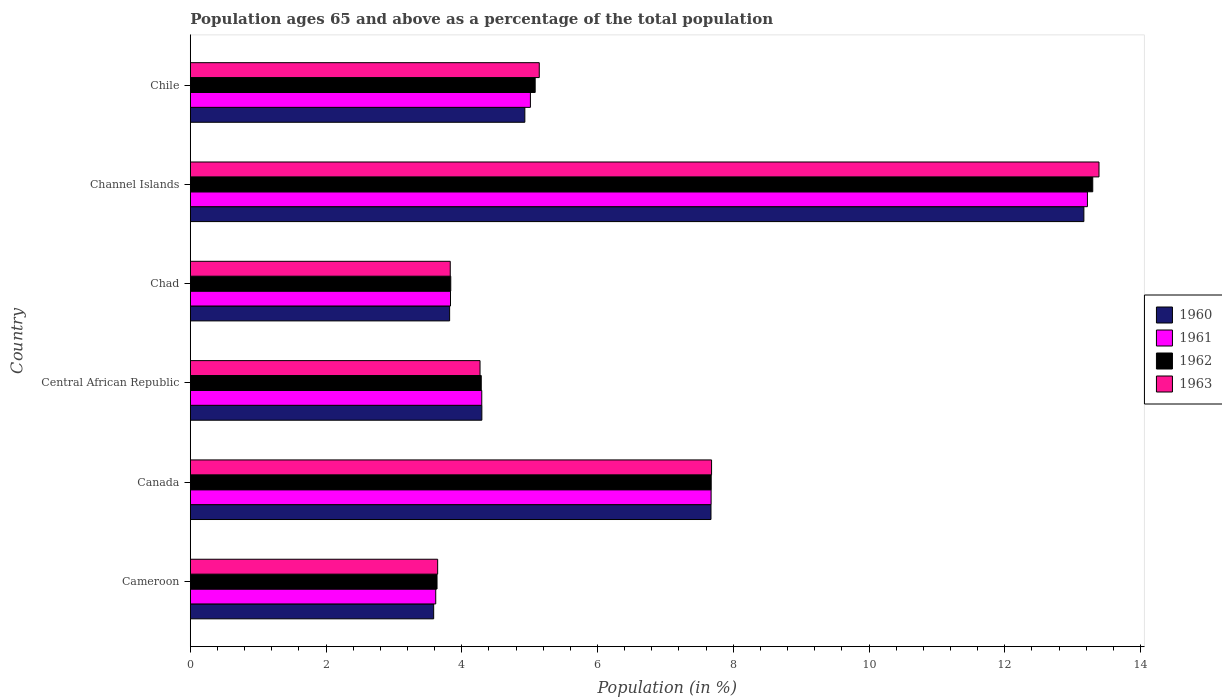How many groups of bars are there?
Offer a terse response. 6. Are the number of bars per tick equal to the number of legend labels?
Make the answer very short. Yes. Are the number of bars on each tick of the Y-axis equal?
Your answer should be very brief. Yes. How many bars are there on the 6th tick from the bottom?
Your answer should be compact. 4. What is the label of the 2nd group of bars from the top?
Offer a very short reply. Channel Islands. In how many cases, is the number of bars for a given country not equal to the number of legend labels?
Ensure brevity in your answer.  0. What is the percentage of the population ages 65 and above in 1960 in Channel Islands?
Keep it short and to the point. 13.17. Across all countries, what is the maximum percentage of the population ages 65 and above in 1962?
Provide a short and direct response. 13.3. Across all countries, what is the minimum percentage of the population ages 65 and above in 1962?
Keep it short and to the point. 3.64. In which country was the percentage of the population ages 65 and above in 1961 maximum?
Offer a very short reply. Channel Islands. In which country was the percentage of the population ages 65 and above in 1963 minimum?
Offer a terse response. Cameroon. What is the total percentage of the population ages 65 and above in 1962 in the graph?
Offer a terse response. 37.81. What is the difference between the percentage of the population ages 65 and above in 1963 in Canada and that in Central African Republic?
Your response must be concise. 3.41. What is the difference between the percentage of the population ages 65 and above in 1963 in Chad and the percentage of the population ages 65 and above in 1962 in Cameroon?
Provide a succinct answer. 0.19. What is the average percentage of the population ages 65 and above in 1960 per country?
Ensure brevity in your answer.  6.24. What is the difference between the percentage of the population ages 65 and above in 1960 and percentage of the population ages 65 and above in 1961 in Cameroon?
Offer a terse response. -0.03. In how many countries, is the percentage of the population ages 65 and above in 1962 greater than 1.6 ?
Your answer should be very brief. 6. What is the ratio of the percentage of the population ages 65 and above in 1961 in Canada to that in Central African Republic?
Offer a very short reply. 1.79. Is the difference between the percentage of the population ages 65 and above in 1960 in Canada and Chad greater than the difference between the percentage of the population ages 65 and above in 1961 in Canada and Chad?
Your answer should be very brief. Yes. What is the difference between the highest and the second highest percentage of the population ages 65 and above in 1962?
Your response must be concise. 5.62. What is the difference between the highest and the lowest percentage of the population ages 65 and above in 1961?
Ensure brevity in your answer.  9.6. In how many countries, is the percentage of the population ages 65 and above in 1963 greater than the average percentage of the population ages 65 and above in 1963 taken over all countries?
Keep it short and to the point. 2. What does the 4th bar from the top in Central African Republic represents?
Your answer should be compact. 1960. Is it the case that in every country, the sum of the percentage of the population ages 65 and above in 1961 and percentage of the population ages 65 and above in 1963 is greater than the percentage of the population ages 65 and above in 1962?
Your response must be concise. Yes. How many bars are there?
Your answer should be very brief. 24. Are all the bars in the graph horizontal?
Ensure brevity in your answer.  Yes. How many countries are there in the graph?
Your answer should be very brief. 6. What is the difference between two consecutive major ticks on the X-axis?
Provide a short and direct response. 2. Does the graph contain grids?
Keep it short and to the point. No. Where does the legend appear in the graph?
Give a very brief answer. Center right. What is the title of the graph?
Your answer should be very brief. Population ages 65 and above as a percentage of the total population. What is the Population (in %) of 1960 in Cameroon?
Give a very brief answer. 3.59. What is the Population (in %) of 1961 in Cameroon?
Offer a very short reply. 3.62. What is the Population (in %) of 1962 in Cameroon?
Provide a short and direct response. 3.64. What is the Population (in %) of 1963 in Cameroon?
Provide a short and direct response. 3.64. What is the Population (in %) in 1960 in Canada?
Provide a short and direct response. 7.67. What is the Population (in %) of 1961 in Canada?
Provide a short and direct response. 7.67. What is the Population (in %) in 1962 in Canada?
Make the answer very short. 7.68. What is the Population (in %) of 1963 in Canada?
Offer a terse response. 7.68. What is the Population (in %) of 1960 in Central African Republic?
Offer a very short reply. 4.3. What is the Population (in %) in 1961 in Central African Republic?
Provide a succinct answer. 4.29. What is the Population (in %) in 1962 in Central African Republic?
Your answer should be compact. 4.29. What is the Population (in %) in 1963 in Central African Republic?
Provide a short and direct response. 4.27. What is the Population (in %) in 1960 in Chad?
Offer a terse response. 3.82. What is the Population (in %) of 1961 in Chad?
Make the answer very short. 3.83. What is the Population (in %) of 1962 in Chad?
Provide a short and direct response. 3.84. What is the Population (in %) in 1963 in Chad?
Offer a very short reply. 3.83. What is the Population (in %) in 1960 in Channel Islands?
Make the answer very short. 13.17. What is the Population (in %) in 1961 in Channel Islands?
Ensure brevity in your answer.  13.22. What is the Population (in %) of 1962 in Channel Islands?
Your response must be concise. 13.3. What is the Population (in %) in 1963 in Channel Islands?
Make the answer very short. 13.39. What is the Population (in %) of 1960 in Chile?
Keep it short and to the point. 4.93. What is the Population (in %) of 1961 in Chile?
Offer a terse response. 5.01. What is the Population (in %) of 1962 in Chile?
Your answer should be compact. 5.08. What is the Population (in %) in 1963 in Chile?
Your answer should be very brief. 5.14. Across all countries, what is the maximum Population (in %) of 1960?
Your answer should be compact. 13.17. Across all countries, what is the maximum Population (in %) of 1961?
Make the answer very short. 13.22. Across all countries, what is the maximum Population (in %) in 1962?
Provide a short and direct response. 13.3. Across all countries, what is the maximum Population (in %) of 1963?
Your answer should be compact. 13.39. Across all countries, what is the minimum Population (in %) in 1960?
Keep it short and to the point. 3.59. Across all countries, what is the minimum Population (in %) of 1961?
Your response must be concise. 3.62. Across all countries, what is the minimum Population (in %) of 1962?
Provide a short and direct response. 3.64. Across all countries, what is the minimum Population (in %) of 1963?
Your response must be concise. 3.64. What is the total Population (in %) in 1960 in the graph?
Ensure brevity in your answer.  37.47. What is the total Population (in %) of 1961 in the graph?
Offer a very short reply. 37.65. What is the total Population (in %) in 1962 in the graph?
Keep it short and to the point. 37.81. What is the total Population (in %) in 1963 in the graph?
Offer a terse response. 37.95. What is the difference between the Population (in %) in 1960 in Cameroon and that in Canada?
Your answer should be compact. -4.09. What is the difference between the Population (in %) of 1961 in Cameroon and that in Canada?
Provide a short and direct response. -4.06. What is the difference between the Population (in %) in 1962 in Cameroon and that in Canada?
Provide a short and direct response. -4.04. What is the difference between the Population (in %) in 1963 in Cameroon and that in Canada?
Your response must be concise. -4.04. What is the difference between the Population (in %) of 1960 in Cameroon and that in Central African Republic?
Your answer should be very brief. -0.71. What is the difference between the Population (in %) in 1961 in Cameroon and that in Central African Republic?
Offer a terse response. -0.68. What is the difference between the Population (in %) of 1962 in Cameroon and that in Central African Republic?
Offer a very short reply. -0.65. What is the difference between the Population (in %) of 1963 in Cameroon and that in Central African Republic?
Make the answer very short. -0.62. What is the difference between the Population (in %) in 1960 in Cameroon and that in Chad?
Your answer should be very brief. -0.24. What is the difference between the Population (in %) in 1961 in Cameroon and that in Chad?
Your answer should be very brief. -0.22. What is the difference between the Population (in %) in 1962 in Cameroon and that in Chad?
Your response must be concise. -0.2. What is the difference between the Population (in %) in 1963 in Cameroon and that in Chad?
Offer a terse response. -0.19. What is the difference between the Population (in %) in 1960 in Cameroon and that in Channel Islands?
Provide a short and direct response. -9.58. What is the difference between the Population (in %) of 1961 in Cameroon and that in Channel Islands?
Offer a very short reply. -9.6. What is the difference between the Population (in %) of 1962 in Cameroon and that in Channel Islands?
Provide a succinct answer. -9.66. What is the difference between the Population (in %) in 1963 in Cameroon and that in Channel Islands?
Offer a terse response. -9.74. What is the difference between the Population (in %) in 1960 in Cameroon and that in Chile?
Offer a very short reply. -1.34. What is the difference between the Population (in %) of 1961 in Cameroon and that in Chile?
Keep it short and to the point. -1.4. What is the difference between the Population (in %) of 1962 in Cameroon and that in Chile?
Ensure brevity in your answer.  -1.45. What is the difference between the Population (in %) of 1963 in Cameroon and that in Chile?
Offer a very short reply. -1.5. What is the difference between the Population (in %) of 1960 in Canada and that in Central African Republic?
Ensure brevity in your answer.  3.38. What is the difference between the Population (in %) of 1961 in Canada and that in Central African Republic?
Offer a terse response. 3.38. What is the difference between the Population (in %) in 1962 in Canada and that in Central African Republic?
Offer a very short reply. 3.39. What is the difference between the Population (in %) in 1963 in Canada and that in Central African Republic?
Provide a short and direct response. 3.41. What is the difference between the Population (in %) in 1960 in Canada and that in Chad?
Provide a succinct answer. 3.85. What is the difference between the Population (in %) of 1961 in Canada and that in Chad?
Offer a terse response. 3.84. What is the difference between the Population (in %) of 1962 in Canada and that in Chad?
Provide a short and direct response. 3.84. What is the difference between the Population (in %) in 1963 in Canada and that in Chad?
Give a very brief answer. 3.85. What is the difference between the Population (in %) of 1960 in Canada and that in Channel Islands?
Provide a succinct answer. -5.49. What is the difference between the Population (in %) in 1961 in Canada and that in Channel Islands?
Your answer should be compact. -5.54. What is the difference between the Population (in %) in 1962 in Canada and that in Channel Islands?
Offer a very short reply. -5.62. What is the difference between the Population (in %) in 1963 in Canada and that in Channel Islands?
Provide a succinct answer. -5.71. What is the difference between the Population (in %) of 1960 in Canada and that in Chile?
Your answer should be compact. 2.74. What is the difference between the Population (in %) in 1961 in Canada and that in Chile?
Give a very brief answer. 2.66. What is the difference between the Population (in %) of 1962 in Canada and that in Chile?
Your response must be concise. 2.59. What is the difference between the Population (in %) in 1963 in Canada and that in Chile?
Offer a terse response. 2.54. What is the difference between the Population (in %) of 1960 in Central African Republic and that in Chad?
Give a very brief answer. 0.47. What is the difference between the Population (in %) in 1961 in Central African Republic and that in Chad?
Make the answer very short. 0.46. What is the difference between the Population (in %) in 1962 in Central African Republic and that in Chad?
Offer a very short reply. 0.45. What is the difference between the Population (in %) of 1963 in Central African Republic and that in Chad?
Provide a succinct answer. 0.44. What is the difference between the Population (in %) in 1960 in Central African Republic and that in Channel Islands?
Provide a succinct answer. -8.87. What is the difference between the Population (in %) of 1961 in Central African Republic and that in Channel Islands?
Your response must be concise. -8.92. What is the difference between the Population (in %) in 1962 in Central African Republic and that in Channel Islands?
Ensure brevity in your answer.  -9.01. What is the difference between the Population (in %) of 1963 in Central African Republic and that in Channel Islands?
Give a very brief answer. -9.12. What is the difference between the Population (in %) in 1960 in Central African Republic and that in Chile?
Ensure brevity in your answer.  -0.63. What is the difference between the Population (in %) of 1961 in Central African Republic and that in Chile?
Give a very brief answer. -0.72. What is the difference between the Population (in %) of 1962 in Central African Republic and that in Chile?
Keep it short and to the point. -0.79. What is the difference between the Population (in %) in 1963 in Central African Republic and that in Chile?
Make the answer very short. -0.87. What is the difference between the Population (in %) of 1960 in Chad and that in Channel Islands?
Ensure brevity in your answer.  -9.35. What is the difference between the Population (in %) of 1961 in Chad and that in Channel Islands?
Keep it short and to the point. -9.38. What is the difference between the Population (in %) in 1962 in Chad and that in Channel Islands?
Offer a very short reply. -9.46. What is the difference between the Population (in %) in 1963 in Chad and that in Channel Islands?
Keep it short and to the point. -9.56. What is the difference between the Population (in %) in 1960 in Chad and that in Chile?
Give a very brief answer. -1.11. What is the difference between the Population (in %) of 1961 in Chad and that in Chile?
Provide a short and direct response. -1.18. What is the difference between the Population (in %) of 1962 in Chad and that in Chile?
Keep it short and to the point. -1.24. What is the difference between the Population (in %) in 1963 in Chad and that in Chile?
Ensure brevity in your answer.  -1.31. What is the difference between the Population (in %) of 1960 in Channel Islands and that in Chile?
Offer a terse response. 8.24. What is the difference between the Population (in %) in 1961 in Channel Islands and that in Chile?
Your answer should be compact. 8.21. What is the difference between the Population (in %) of 1962 in Channel Islands and that in Chile?
Your response must be concise. 8.22. What is the difference between the Population (in %) in 1963 in Channel Islands and that in Chile?
Offer a terse response. 8.25. What is the difference between the Population (in %) in 1960 in Cameroon and the Population (in %) in 1961 in Canada?
Offer a terse response. -4.09. What is the difference between the Population (in %) in 1960 in Cameroon and the Population (in %) in 1962 in Canada?
Your answer should be compact. -4.09. What is the difference between the Population (in %) in 1960 in Cameroon and the Population (in %) in 1963 in Canada?
Offer a very short reply. -4.09. What is the difference between the Population (in %) of 1961 in Cameroon and the Population (in %) of 1962 in Canada?
Offer a very short reply. -4.06. What is the difference between the Population (in %) of 1961 in Cameroon and the Population (in %) of 1963 in Canada?
Offer a terse response. -4.06. What is the difference between the Population (in %) of 1962 in Cameroon and the Population (in %) of 1963 in Canada?
Give a very brief answer. -4.05. What is the difference between the Population (in %) in 1960 in Cameroon and the Population (in %) in 1961 in Central African Republic?
Provide a short and direct response. -0.71. What is the difference between the Population (in %) in 1960 in Cameroon and the Population (in %) in 1962 in Central African Republic?
Provide a succinct answer. -0.7. What is the difference between the Population (in %) of 1960 in Cameroon and the Population (in %) of 1963 in Central African Republic?
Your response must be concise. -0.68. What is the difference between the Population (in %) in 1961 in Cameroon and the Population (in %) in 1962 in Central African Republic?
Your answer should be very brief. -0.67. What is the difference between the Population (in %) of 1961 in Cameroon and the Population (in %) of 1963 in Central African Republic?
Your response must be concise. -0.65. What is the difference between the Population (in %) of 1962 in Cameroon and the Population (in %) of 1963 in Central African Republic?
Ensure brevity in your answer.  -0.63. What is the difference between the Population (in %) in 1960 in Cameroon and the Population (in %) in 1961 in Chad?
Offer a very short reply. -0.25. What is the difference between the Population (in %) of 1960 in Cameroon and the Population (in %) of 1962 in Chad?
Provide a succinct answer. -0.25. What is the difference between the Population (in %) in 1960 in Cameroon and the Population (in %) in 1963 in Chad?
Your answer should be compact. -0.24. What is the difference between the Population (in %) of 1961 in Cameroon and the Population (in %) of 1962 in Chad?
Offer a terse response. -0.22. What is the difference between the Population (in %) in 1961 in Cameroon and the Population (in %) in 1963 in Chad?
Ensure brevity in your answer.  -0.21. What is the difference between the Population (in %) in 1962 in Cameroon and the Population (in %) in 1963 in Chad?
Make the answer very short. -0.19. What is the difference between the Population (in %) in 1960 in Cameroon and the Population (in %) in 1961 in Channel Islands?
Give a very brief answer. -9.63. What is the difference between the Population (in %) in 1960 in Cameroon and the Population (in %) in 1962 in Channel Islands?
Ensure brevity in your answer.  -9.71. What is the difference between the Population (in %) in 1960 in Cameroon and the Population (in %) in 1963 in Channel Islands?
Ensure brevity in your answer.  -9.8. What is the difference between the Population (in %) in 1961 in Cameroon and the Population (in %) in 1962 in Channel Islands?
Offer a terse response. -9.68. What is the difference between the Population (in %) of 1961 in Cameroon and the Population (in %) of 1963 in Channel Islands?
Your answer should be compact. -9.77. What is the difference between the Population (in %) of 1962 in Cameroon and the Population (in %) of 1963 in Channel Islands?
Give a very brief answer. -9.75. What is the difference between the Population (in %) of 1960 in Cameroon and the Population (in %) of 1961 in Chile?
Your answer should be very brief. -1.43. What is the difference between the Population (in %) in 1960 in Cameroon and the Population (in %) in 1962 in Chile?
Offer a terse response. -1.5. What is the difference between the Population (in %) in 1960 in Cameroon and the Population (in %) in 1963 in Chile?
Your answer should be compact. -1.56. What is the difference between the Population (in %) in 1961 in Cameroon and the Population (in %) in 1962 in Chile?
Keep it short and to the point. -1.47. What is the difference between the Population (in %) in 1961 in Cameroon and the Population (in %) in 1963 in Chile?
Provide a short and direct response. -1.53. What is the difference between the Population (in %) in 1962 in Cameroon and the Population (in %) in 1963 in Chile?
Offer a terse response. -1.51. What is the difference between the Population (in %) in 1960 in Canada and the Population (in %) in 1961 in Central African Republic?
Give a very brief answer. 3.38. What is the difference between the Population (in %) of 1960 in Canada and the Population (in %) of 1962 in Central African Republic?
Ensure brevity in your answer.  3.38. What is the difference between the Population (in %) of 1960 in Canada and the Population (in %) of 1963 in Central African Republic?
Your answer should be compact. 3.4. What is the difference between the Population (in %) of 1961 in Canada and the Population (in %) of 1962 in Central African Republic?
Your answer should be compact. 3.39. What is the difference between the Population (in %) in 1961 in Canada and the Population (in %) in 1963 in Central African Republic?
Keep it short and to the point. 3.4. What is the difference between the Population (in %) in 1962 in Canada and the Population (in %) in 1963 in Central African Republic?
Provide a succinct answer. 3.41. What is the difference between the Population (in %) of 1960 in Canada and the Population (in %) of 1961 in Chad?
Your answer should be very brief. 3.84. What is the difference between the Population (in %) of 1960 in Canada and the Population (in %) of 1962 in Chad?
Your answer should be compact. 3.83. What is the difference between the Population (in %) of 1960 in Canada and the Population (in %) of 1963 in Chad?
Your answer should be very brief. 3.84. What is the difference between the Population (in %) of 1961 in Canada and the Population (in %) of 1962 in Chad?
Your response must be concise. 3.84. What is the difference between the Population (in %) in 1961 in Canada and the Population (in %) in 1963 in Chad?
Your response must be concise. 3.84. What is the difference between the Population (in %) of 1962 in Canada and the Population (in %) of 1963 in Chad?
Make the answer very short. 3.84. What is the difference between the Population (in %) of 1960 in Canada and the Population (in %) of 1961 in Channel Islands?
Your answer should be very brief. -5.55. What is the difference between the Population (in %) in 1960 in Canada and the Population (in %) in 1962 in Channel Islands?
Ensure brevity in your answer.  -5.62. What is the difference between the Population (in %) of 1960 in Canada and the Population (in %) of 1963 in Channel Islands?
Provide a short and direct response. -5.72. What is the difference between the Population (in %) of 1961 in Canada and the Population (in %) of 1962 in Channel Islands?
Offer a terse response. -5.62. What is the difference between the Population (in %) in 1961 in Canada and the Population (in %) in 1963 in Channel Islands?
Provide a short and direct response. -5.72. What is the difference between the Population (in %) in 1962 in Canada and the Population (in %) in 1963 in Channel Islands?
Provide a short and direct response. -5.71. What is the difference between the Population (in %) in 1960 in Canada and the Population (in %) in 1961 in Chile?
Your answer should be compact. 2.66. What is the difference between the Population (in %) in 1960 in Canada and the Population (in %) in 1962 in Chile?
Provide a succinct answer. 2.59. What is the difference between the Population (in %) of 1960 in Canada and the Population (in %) of 1963 in Chile?
Provide a short and direct response. 2.53. What is the difference between the Population (in %) in 1961 in Canada and the Population (in %) in 1962 in Chile?
Ensure brevity in your answer.  2.59. What is the difference between the Population (in %) of 1961 in Canada and the Population (in %) of 1963 in Chile?
Your response must be concise. 2.53. What is the difference between the Population (in %) in 1962 in Canada and the Population (in %) in 1963 in Chile?
Make the answer very short. 2.53. What is the difference between the Population (in %) in 1960 in Central African Republic and the Population (in %) in 1961 in Chad?
Your answer should be compact. 0.46. What is the difference between the Population (in %) of 1960 in Central African Republic and the Population (in %) of 1962 in Chad?
Make the answer very short. 0.46. What is the difference between the Population (in %) in 1960 in Central African Republic and the Population (in %) in 1963 in Chad?
Provide a short and direct response. 0.47. What is the difference between the Population (in %) of 1961 in Central African Republic and the Population (in %) of 1962 in Chad?
Give a very brief answer. 0.46. What is the difference between the Population (in %) in 1961 in Central African Republic and the Population (in %) in 1963 in Chad?
Ensure brevity in your answer.  0.46. What is the difference between the Population (in %) in 1962 in Central African Republic and the Population (in %) in 1963 in Chad?
Provide a short and direct response. 0.46. What is the difference between the Population (in %) of 1960 in Central African Republic and the Population (in %) of 1961 in Channel Islands?
Make the answer very short. -8.92. What is the difference between the Population (in %) in 1960 in Central African Republic and the Population (in %) in 1962 in Channel Islands?
Your response must be concise. -9. What is the difference between the Population (in %) in 1960 in Central African Republic and the Population (in %) in 1963 in Channel Islands?
Make the answer very short. -9.09. What is the difference between the Population (in %) in 1961 in Central African Republic and the Population (in %) in 1962 in Channel Islands?
Your answer should be compact. -9. What is the difference between the Population (in %) in 1961 in Central African Republic and the Population (in %) in 1963 in Channel Islands?
Your answer should be compact. -9.09. What is the difference between the Population (in %) in 1962 in Central African Republic and the Population (in %) in 1963 in Channel Islands?
Your response must be concise. -9.1. What is the difference between the Population (in %) of 1960 in Central African Republic and the Population (in %) of 1961 in Chile?
Make the answer very short. -0.72. What is the difference between the Population (in %) in 1960 in Central African Republic and the Population (in %) in 1962 in Chile?
Offer a terse response. -0.79. What is the difference between the Population (in %) of 1960 in Central African Republic and the Population (in %) of 1963 in Chile?
Provide a succinct answer. -0.85. What is the difference between the Population (in %) of 1961 in Central African Republic and the Population (in %) of 1962 in Chile?
Your answer should be compact. -0.79. What is the difference between the Population (in %) of 1961 in Central African Republic and the Population (in %) of 1963 in Chile?
Keep it short and to the point. -0.85. What is the difference between the Population (in %) of 1962 in Central African Republic and the Population (in %) of 1963 in Chile?
Offer a very short reply. -0.85. What is the difference between the Population (in %) of 1960 in Chad and the Population (in %) of 1961 in Channel Islands?
Offer a very short reply. -9.4. What is the difference between the Population (in %) in 1960 in Chad and the Population (in %) in 1962 in Channel Islands?
Offer a very short reply. -9.48. What is the difference between the Population (in %) in 1960 in Chad and the Population (in %) in 1963 in Channel Islands?
Offer a very short reply. -9.57. What is the difference between the Population (in %) of 1961 in Chad and the Population (in %) of 1962 in Channel Islands?
Give a very brief answer. -9.46. What is the difference between the Population (in %) of 1961 in Chad and the Population (in %) of 1963 in Channel Islands?
Provide a short and direct response. -9.55. What is the difference between the Population (in %) of 1962 in Chad and the Population (in %) of 1963 in Channel Islands?
Your response must be concise. -9.55. What is the difference between the Population (in %) of 1960 in Chad and the Population (in %) of 1961 in Chile?
Your answer should be very brief. -1.19. What is the difference between the Population (in %) in 1960 in Chad and the Population (in %) in 1962 in Chile?
Keep it short and to the point. -1.26. What is the difference between the Population (in %) of 1960 in Chad and the Population (in %) of 1963 in Chile?
Your answer should be very brief. -1.32. What is the difference between the Population (in %) in 1961 in Chad and the Population (in %) in 1962 in Chile?
Make the answer very short. -1.25. What is the difference between the Population (in %) in 1961 in Chad and the Population (in %) in 1963 in Chile?
Your answer should be compact. -1.31. What is the difference between the Population (in %) in 1962 in Chad and the Population (in %) in 1963 in Chile?
Give a very brief answer. -1.3. What is the difference between the Population (in %) in 1960 in Channel Islands and the Population (in %) in 1961 in Chile?
Keep it short and to the point. 8.15. What is the difference between the Population (in %) in 1960 in Channel Islands and the Population (in %) in 1962 in Chile?
Your response must be concise. 8.08. What is the difference between the Population (in %) of 1960 in Channel Islands and the Population (in %) of 1963 in Chile?
Keep it short and to the point. 8.02. What is the difference between the Population (in %) in 1961 in Channel Islands and the Population (in %) in 1962 in Chile?
Your response must be concise. 8.14. What is the difference between the Population (in %) of 1961 in Channel Islands and the Population (in %) of 1963 in Chile?
Your answer should be compact. 8.08. What is the difference between the Population (in %) in 1962 in Channel Islands and the Population (in %) in 1963 in Chile?
Provide a succinct answer. 8.16. What is the average Population (in %) in 1960 per country?
Give a very brief answer. 6.25. What is the average Population (in %) in 1961 per country?
Provide a succinct answer. 6.27. What is the average Population (in %) in 1962 per country?
Provide a succinct answer. 6.3. What is the average Population (in %) of 1963 per country?
Make the answer very short. 6.33. What is the difference between the Population (in %) of 1960 and Population (in %) of 1961 in Cameroon?
Keep it short and to the point. -0.03. What is the difference between the Population (in %) in 1960 and Population (in %) in 1962 in Cameroon?
Give a very brief answer. -0.05. What is the difference between the Population (in %) in 1960 and Population (in %) in 1963 in Cameroon?
Offer a terse response. -0.06. What is the difference between the Population (in %) in 1961 and Population (in %) in 1962 in Cameroon?
Your answer should be very brief. -0.02. What is the difference between the Population (in %) in 1961 and Population (in %) in 1963 in Cameroon?
Offer a very short reply. -0.03. What is the difference between the Population (in %) in 1962 and Population (in %) in 1963 in Cameroon?
Your answer should be compact. -0.01. What is the difference between the Population (in %) of 1960 and Population (in %) of 1961 in Canada?
Make the answer very short. -0. What is the difference between the Population (in %) of 1960 and Population (in %) of 1962 in Canada?
Offer a very short reply. -0. What is the difference between the Population (in %) of 1960 and Population (in %) of 1963 in Canada?
Your response must be concise. -0.01. What is the difference between the Population (in %) of 1961 and Population (in %) of 1962 in Canada?
Keep it short and to the point. -0. What is the difference between the Population (in %) of 1961 and Population (in %) of 1963 in Canada?
Your answer should be compact. -0.01. What is the difference between the Population (in %) of 1962 and Population (in %) of 1963 in Canada?
Keep it short and to the point. -0.01. What is the difference between the Population (in %) in 1960 and Population (in %) in 1961 in Central African Republic?
Make the answer very short. 0. What is the difference between the Population (in %) in 1960 and Population (in %) in 1962 in Central African Republic?
Give a very brief answer. 0.01. What is the difference between the Population (in %) in 1960 and Population (in %) in 1963 in Central African Republic?
Keep it short and to the point. 0.03. What is the difference between the Population (in %) of 1961 and Population (in %) of 1962 in Central African Republic?
Make the answer very short. 0.01. What is the difference between the Population (in %) of 1961 and Population (in %) of 1963 in Central African Republic?
Ensure brevity in your answer.  0.03. What is the difference between the Population (in %) of 1962 and Population (in %) of 1963 in Central African Republic?
Your answer should be compact. 0.02. What is the difference between the Population (in %) of 1960 and Population (in %) of 1961 in Chad?
Make the answer very short. -0.01. What is the difference between the Population (in %) of 1960 and Population (in %) of 1962 in Chad?
Your answer should be very brief. -0.02. What is the difference between the Population (in %) in 1960 and Population (in %) in 1963 in Chad?
Your answer should be compact. -0.01. What is the difference between the Population (in %) in 1961 and Population (in %) in 1962 in Chad?
Give a very brief answer. -0. What is the difference between the Population (in %) in 1961 and Population (in %) in 1963 in Chad?
Provide a short and direct response. 0. What is the difference between the Population (in %) of 1962 and Population (in %) of 1963 in Chad?
Provide a short and direct response. 0.01. What is the difference between the Population (in %) of 1960 and Population (in %) of 1961 in Channel Islands?
Make the answer very short. -0.05. What is the difference between the Population (in %) of 1960 and Population (in %) of 1962 in Channel Islands?
Give a very brief answer. -0.13. What is the difference between the Population (in %) of 1960 and Population (in %) of 1963 in Channel Islands?
Offer a terse response. -0.22. What is the difference between the Population (in %) in 1961 and Population (in %) in 1962 in Channel Islands?
Provide a short and direct response. -0.08. What is the difference between the Population (in %) of 1961 and Population (in %) of 1963 in Channel Islands?
Your answer should be very brief. -0.17. What is the difference between the Population (in %) in 1962 and Population (in %) in 1963 in Channel Islands?
Your response must be concise. -0.09. What is the difference between the Population (in %) of 1960 and Population (in %) of 1961 in Chile?
Your answer should be very brief. -0.08. What is the difference between the Population (in %) in 1960 and Population (in %) in 1962 in Chile?
Keep it short and to the point. -0.15. What is the difference between the Population (in %) in 1960 and Population (in %) in 1963 in Chile?
Offer a terse response. -0.21. What is the difference between the Population (in %) of 1961 and Population (in %) of 1962 in Chile?
Keep it short and to the point. -0.07. What is the difference between the Population (in %) in 1961 and Population (in %) in 1963 in Chile?
Provide a short and direct response. -0.13. What is the difference between the Population (in %) of 1962 and Population (in %) of 1963 in Chile?
Give a very brief answer. -0.06. What is the ratio of the Population (in %) in 1960 in Cameroon to that in Canada?
Provide a short and direct response. 0.47. What is the ratio of the Population (in %) in 1961 in Cameroon to that in Canada?
Your response must be concise. 0.47. What is the ratio of the Population (in %) of 1962 in Cameroon to that in Canada?
Offer a very short reply. 0.47. What is the ratio of the Population (in %) of 1963 in Cameroon to that in Canada?
Make the answer very short. 0.47. What is the ratio of the Population (in %) of 1960 in Cameroon to that in Central African Republic?
Offer a terse response. 0.83. What is the ratio of the Population (in %) in 1961 in Cameroon to that in Central African Republic?
Provide a short and direct response. 0.84. What is the ratio of the Population (in %) in 1962 in Cameroon to that in Central African Republic?
Offer a terse response. 0.85. What is the ratio of the Population (in %) in 1963 in Cameroon to that in Central African Republic?
Ensure brevity in your answer.  0.85. What is the ratio of the Population (in %) in 1960 in Cameroon to that in Chad?
Offer a very short reply. 0.94. What is the ratio of the Population (in %) in 1961 in Cameroon to that in Chad?
Offer a very short reply. 0.94. What is the ratio of the Population (in %) in 1962 in Cameroon to that in Chad?
Provide a short and direct response. 0.95. What is the ratio of the Population (in %) of 1963 in Cameroon to that in Chad?
Offer a very short reply. 0.95. What is the ratio of the Population (in %) of 1960 in Cameroon to that in Channel Islands?
Offer a very short reply. 0.27. What is the ratio of the Population (in %) of 1961 in Cameroon to that in Channel Islands?
Provide a short and direct response. 0.27. What is the ratio of the Population (in %) of 1962 in Cameroon to that in Channel Islands?
Your answer should be very brief. 0.27. What is the ratio of the Population (in %) of 1963 in Cameroon to that in Channel Islands?
Keep it short and to the point. 0.27. What is the ratio of the Population (in %) of 1960 in Cameroon to that in Chile?
Keep it short and to the point. 0.73. What is the ratio of the Population (in %) in 1961 in Cameroon to that in Chile?
Ensure brevity in your answer.  0.72. What is the ratio of the Population (in %) of 1962 in Cameroon to that in Chile?
Give a very brief answer. 0.72. What is the ratio of the Population (in %) in 1963 in Cameroon to that in Chile?
Make the answer very short. 0.71. What is the ratio of the Population (in %) of 1960 in Canada to that in Central African Republic?
Make the answer very short. 1.79. What is the ratio of the Population (in %) of 1961 in Canada to that in Central African Republic?
Your answer should be compact. 1.79. What is the ratio of the Population (in %) of 1962 in Canada to that in Central African Republic?
Offer a terse response. 1.79. What is the ratio of the Population (in %) in 1963 in Canada to that in Central African Republic?
Provide a succinct answer. 1.8. What is the ratio of the Population (in %) in 1960 in Canada to that in Chad?
Give a very brief answer. 2.01. What is the ratio of the Population (in %) in 1961 in Canada to that in Chad?
Offer a very short reply. 2. What is the ratio of the Population (in %) of 1962 in Canada to that in Chad?
Provide a succinct answer. 2. What is the ratio of the Population (in %) in 1963 in Canada to that in Chad?
Offer a very short reply. 2.01. What is the ratio of the Population (in %) in 1960 in Canada to that in Channel Islands?
Your response must be concise. 0.58. What is the ratio of the Population (in %) in 1961 in Canada to that in Channel Islands?
Offer a very short reply. 0.58. What is the ratio of the Population (in %) in 1962 in Canada to that in Channel Islands?
Ensure brevity in your answer.  0.58. What is the ratio of the Population (in %) of 1963 in Canada to that in Channel Islands?
Offer a terse response. 0.57. What is the ratio of the Population (in %) in 1960 in Canada to that in Chile?
Keep it short and to the point. 1.56. What is the ratio of the Population (in %) in 1961 in Canada to that in Chile?
Make the answer very short. 1.53. What is the ratio of the Population (in %) of 1962 in Canada to that in Chile?
Give a very brief answer. 1.51. What is the ratio of the Population (in %) in 1963 in Canada to that in Chile?
Give a very brief answer. 1.49. What is the ratio of the Population (in %) in 1960 in Central African Republic to that in Chad?
Offer a terse response. 1.12. What is the ratio of the Population (in %) in 1961 in Central African Republic to that in Chad?
Your response must be concise. 1.12. What is the ratio of the Population (in %) of 1962 in Central African Republic to that in Chad?
Offer a very short reply. 1.12. What is the ratio of the Population (in %) in 1963 in Central African Republic to that in Chad?
Give a very brief answer. 1.11. What is the ratio of the Population (in %) in 1960 in Central African Republic to that in Channel Islands?
Offer a terse response. 0.33. What is the ratio of the Population (in %) in 1961 in Central African Republic to that in Channel Islands?
Offer a terse response. 0.32. What is the ratio of the Population (in %) in 1962 in Central African Republic to that in Channel Islands?
Your response must be concise. 0.32. What is the ratio of the Population (in %) of 1963 in Central African Republic to that in Channel Islands?
Offer a terse response. 0.32. What is the ratio of the Population (in %) of 1960 in Central African Republic to that in Chile?
Offer a very short reply. 0.87. What is the ratio of the Population (in %) in 1961 in Central African Republic to that in Chile?
Provide a short and direct response. 0.86. What is the ratio of the Population (in %) in 1962 in Central African Republic to that in Chile?
Give a very brief answer. 0.84. What is the ratio of the Population (in %) in 1963 in Central African Republic to that in Chile?
Provide a succinct answer. 0.83. What is the ratio of the Population (in %) in 1960 in Chad to that in Channel Islands?
Give a very brief answer. 0.29. What is the ratio of the Population (in %) in 1961 in Chad to that in Channel Islands?
Offer a terse response. 0.29. What is the ratio of the Population (in %) of 1962 in Chad to that in Channel Islands?
Your answer should be very brief. 0.29. What is the ratio of the Population (in %) in 1963 in Chad to that in Channel Islands?
Your answer should be compact. 0.29. What is the ratio of the Population (in %) in 1960 in Chad to that in Chile?
Keep it short and to the point. 0.78. What is the ratio of the Population (in %) in 1961 in Chad to that in Chile?
Offer a very short reply. 0.77. What is the ratio of the Population (in %) in 1962 in Chad to that in Chile?
Ensure brevity in your answer.  0.76. What is the ratio of the Population (in %) in 1963 in Chad to that in Chile?
Make the answer very short. 0.74. What is the ratio of the Population (in %) of 1960 in Channel Islands to that in Chile?
Make the answer very short. 2.67. What is the ratio of the Population (in %) in 1961 in Channel Islands to that in Chile?
Your response must be concise. 2.64. What is the ratio of the Population (in %) of 1962 in Channel Islands to that in Chile?
Offer a terse response. 2.62. What is the ratio of the Population (in %) of 1963 in Channel Islands to that in Chile?
Your response must be concise. 2.6. What is the difference between the highest and the second highest Population (in %) in 1960?
Your answer should be compact. 5.49. What is the difference between the highest and the second highest Population (in %) in 1961?
Make the answer very short. 5.54. What is the difference between the highest and the second highest Population (in %) in 1962?
Provide a succinct answer. 5.62. What is the difference between the highest and the second highest Population (in %) of 1963?
Provide a succinct answer. 5.71. What is the difference between the highest and the lowest Population (in %) in 1960?
Give a very brief answer. 9.58. What is the difference between the highest and the lowest Population (in %) of 1961?
Provide a succinct answer. 9.6. What is the difference between the highest and the lowest Population (in %) in 1962?
Provide a succinct answer. 9.66. What is the difference between the highest and the lowest Population (in %) in 1963?
Your answer should be very brief. 9.74. 